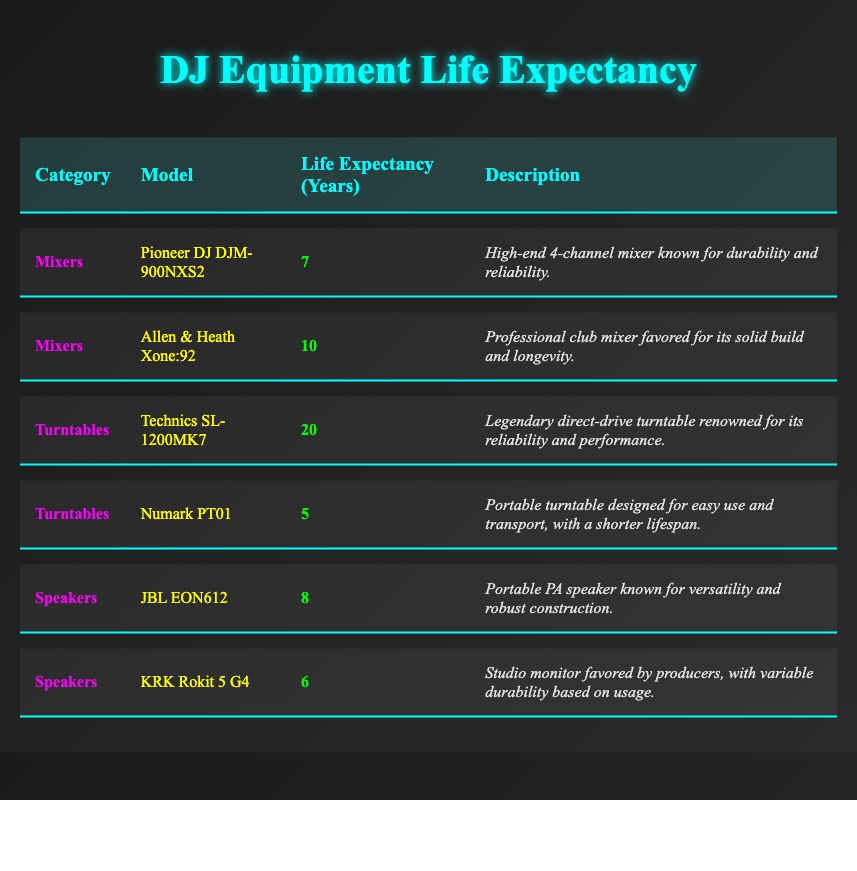What is the average life expectancy of mixers? To find the average life expectancy of mixers, I will locate all the mixers in the table (Pioneer DJ DJM-900NXS2 and Allen & Heath Xone:92) and take the average of their life expectancies: (7 + 10) / 2 = 8.5 years.
Answer: 8.5 Which DJ equipment has the longest life expectancy? The longest life expectancy is found by comparing all equipment. The Technics SL-1200MK7 has a life expectancy of 20 years, which is longer than any other model listed.
Answer: Technics SL-1200MK7 Is the KRK Rokit 5 G4 life expectancy less than 6 years? The life expectancy of KRK Rokit 5 G4 is 6 years, which means it is not less than 6 years, making this statement false.
Answer: No How many categories of DJ equipment are listed in the table? By examining the table, there are three categories presented: Mixers, Turntables, and Speakers. Therefore, the count of categories is 3.
Answer: 3 What is the total life expectancy of all speakers combined? To obtain the total life expectancy of all speakers, sum the life expectancies of the JBL EON612 (8 years) and KRK Rokit 5 G4 (6 years): 8 + 6 = 14 years.
Answer: 14 Does the Numark PT01 have a shorter lifespan than the Pioneer DJ DJM-900NXS2? The life expectancy of Numark PT01 is 5 years, while that of Pioneer DJ DJM-900NXS2 is 7 years, confirming that Numark PT01 has a shorter lifespan.
Answer: Yes How does the average life expectancy of turntables compare to that of mixers? First, calculate the average for turntables: (20 + 5) / 2 = 12.5 years. Compare it with mixers: (7 + 10) / 2 = 8.5 years. Since 12.5 is greater than 8.5, turntables have a higher average life expectancy.
Answer: Turntables have a higher average Which equipment provides the least life expectancy? The least life expectancy can be found by comparing all values; the Numark PT01 has the lowest at 5 years among all listed equipment.
Answer: Numark PT01 What is the total number of DJ equipment models listed in the table? Counting all the models, there are six listed: Pioneer DJ DJM-900NXS2, Allen & Heath Xone:92, Technics SL-1200MK7, Numark PT01, JBL EON612, and KRK Rokit 5 G4. Thus, the total count is 6.
Answer: 6 Which category has the highest maximum life expectancy model? Checking for the highest life expectancy in each category shows that the Technics SL-1200MK7, a turntable, has the longest at 20 years, making this category the one with the highest maximum life expectancy model.
Answer: Turntables have the highest maximum 